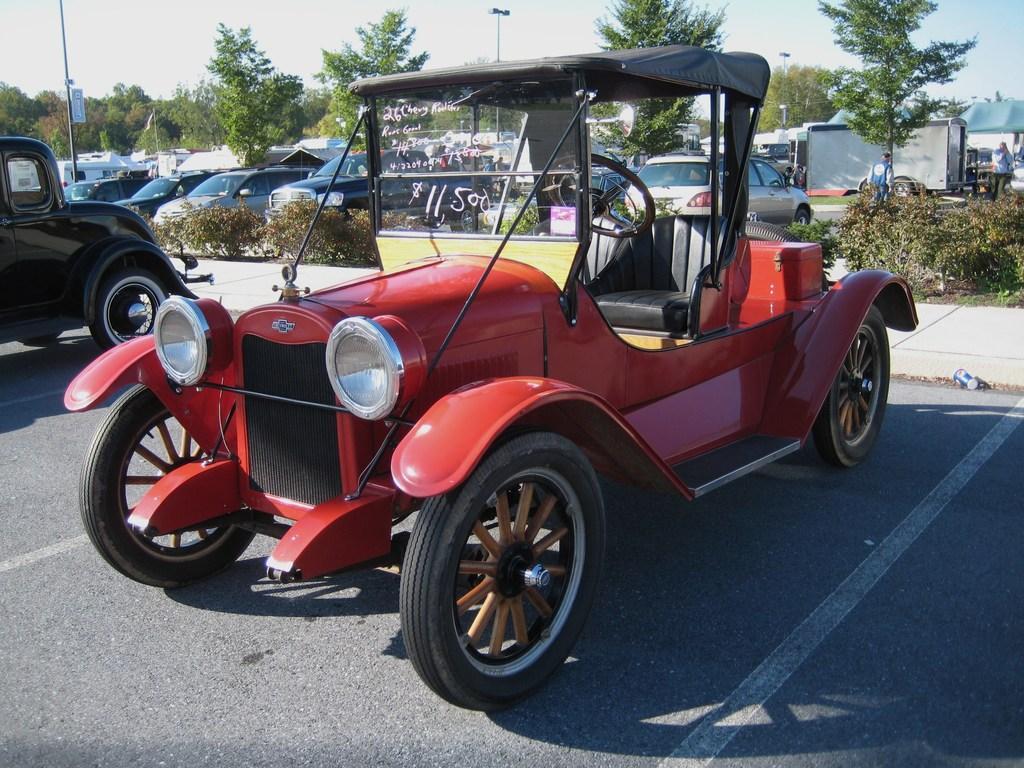Can you describe this image briefly? There is a red color jeep. On the glass of the jeep something is written. In the back there are many vehicles, plants and trees. In the background there is sky. 